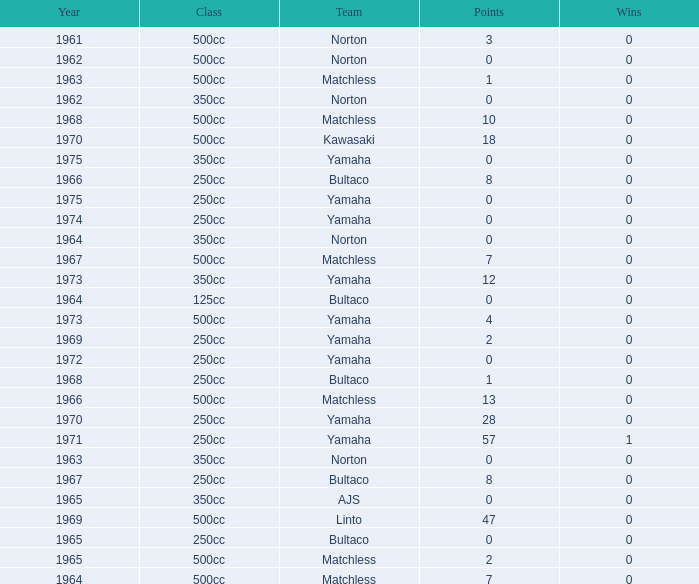What is the average wins in 250cc class for Bultaco with 8 points later than 1966? 0.0. 